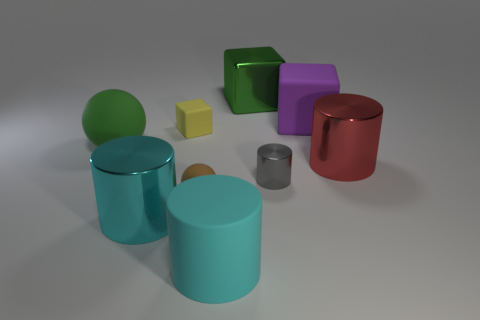Describe the relative positions of the metal cylinders. Certainly! At the center of the image, we have a cyan metal cylinder, and to its immediate left is another, smaller gray metal cylinder. To the right side of this central cyan cylinder, there's a large red metal cylinder, creating a triangular arrangement with the other two cylinders. 